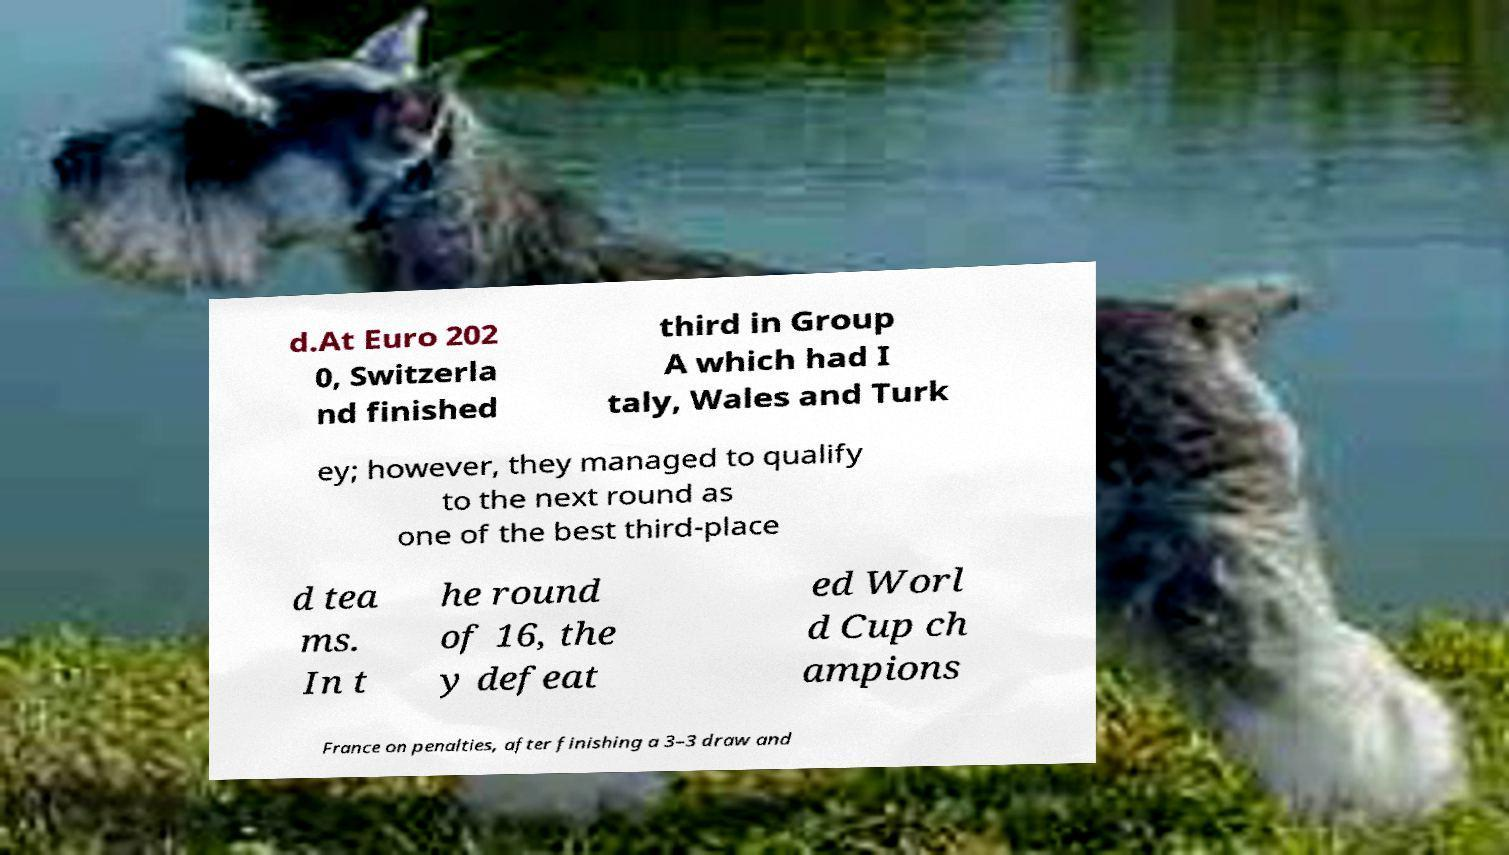Please identify and transcribe the text found in this image. d.At Euro 202 0, Switzerla nd finished third in Group A which had I taly, Wales and Turk ey; however, they managed to qualify to the next round as one of the best third-place d tea ms. In t he round of 16, the y defeat ed Worl d Cup ch ampions France on penalties, after finishing a 3–3 draw and 